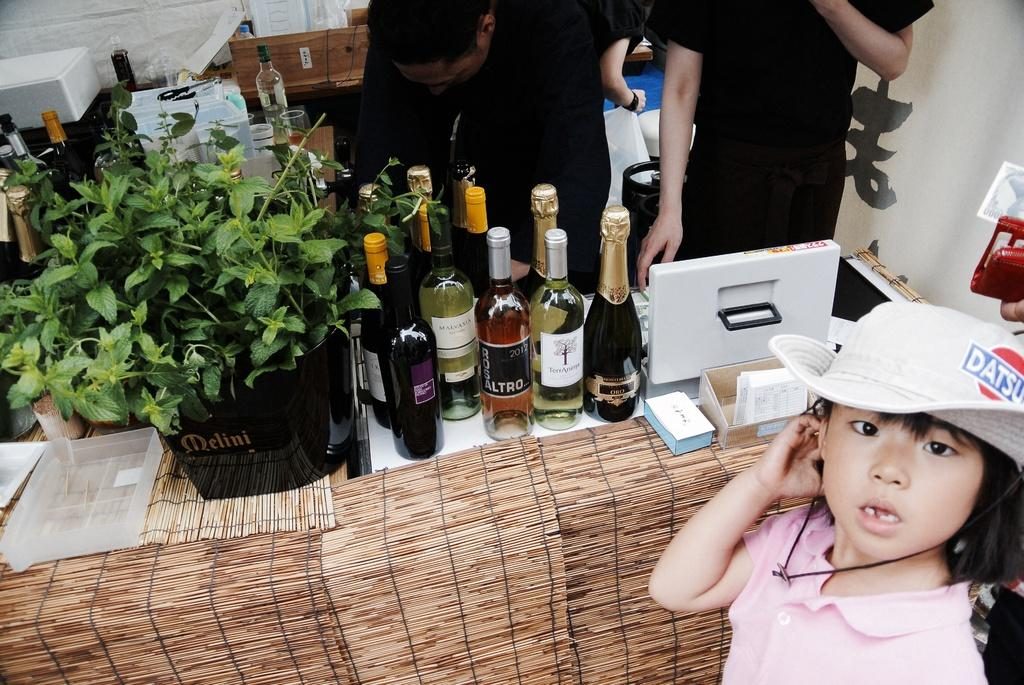Who is the main subject in the image? There is a girl in the image. What is the girl doing in the image? The girl is standing. What is the girl wearing on her head? The girl is wearing a white cap. What can be seen on the table in the image? There are wine bottles on a table in the image. What is happening in the background of the image? There are people standing in the background of the image. What type of fowl can be seen in the image? There is no fowl present in the image. Is the girl in the image receiving treatment for a wound? There is no indication of a wound or any medical treatment in the image. 